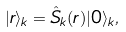<formula> <loc_0><loc_0><loc_500><loc_500>| r \rangle _ { k } = \hat { S } _ { k } ( r ) | 0 \rangle _ { k } ,</formula> 